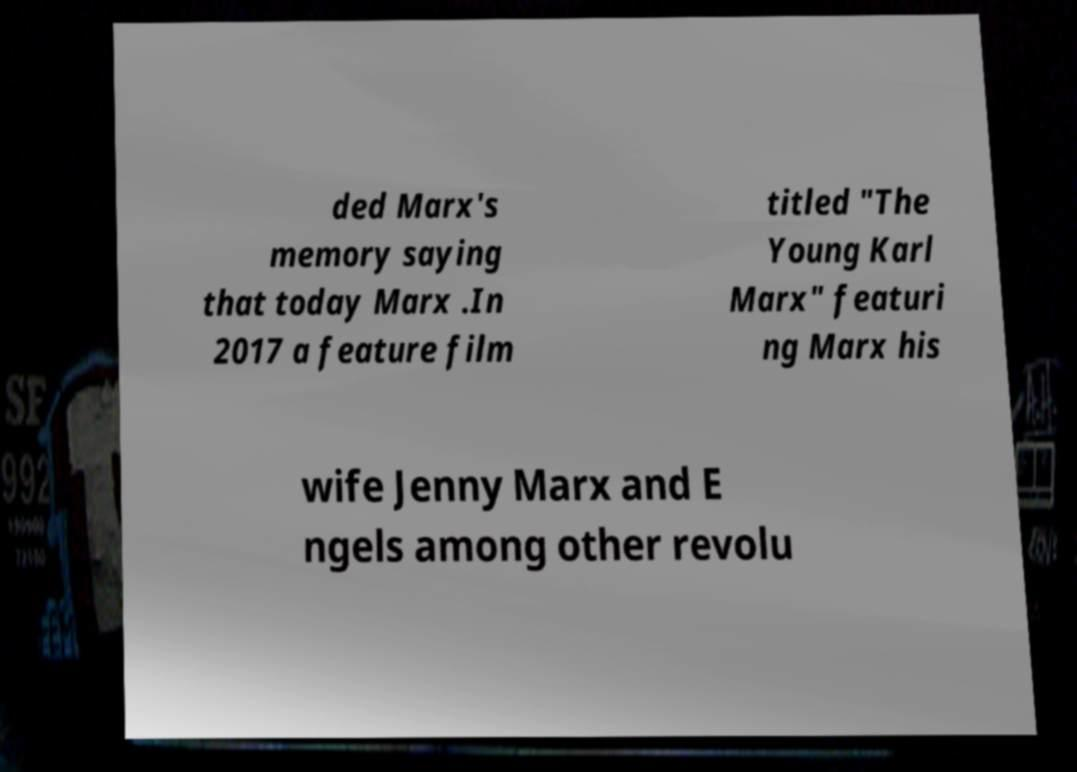What messages or text are displayed in this image? I need them in a readable, typed format. ded Marx's memory saying that today Marx .In 2017 a feature film titled "The Young Karl Marx" featuri ng Marx his wife Jenny Marx and E ngels among other revolu 